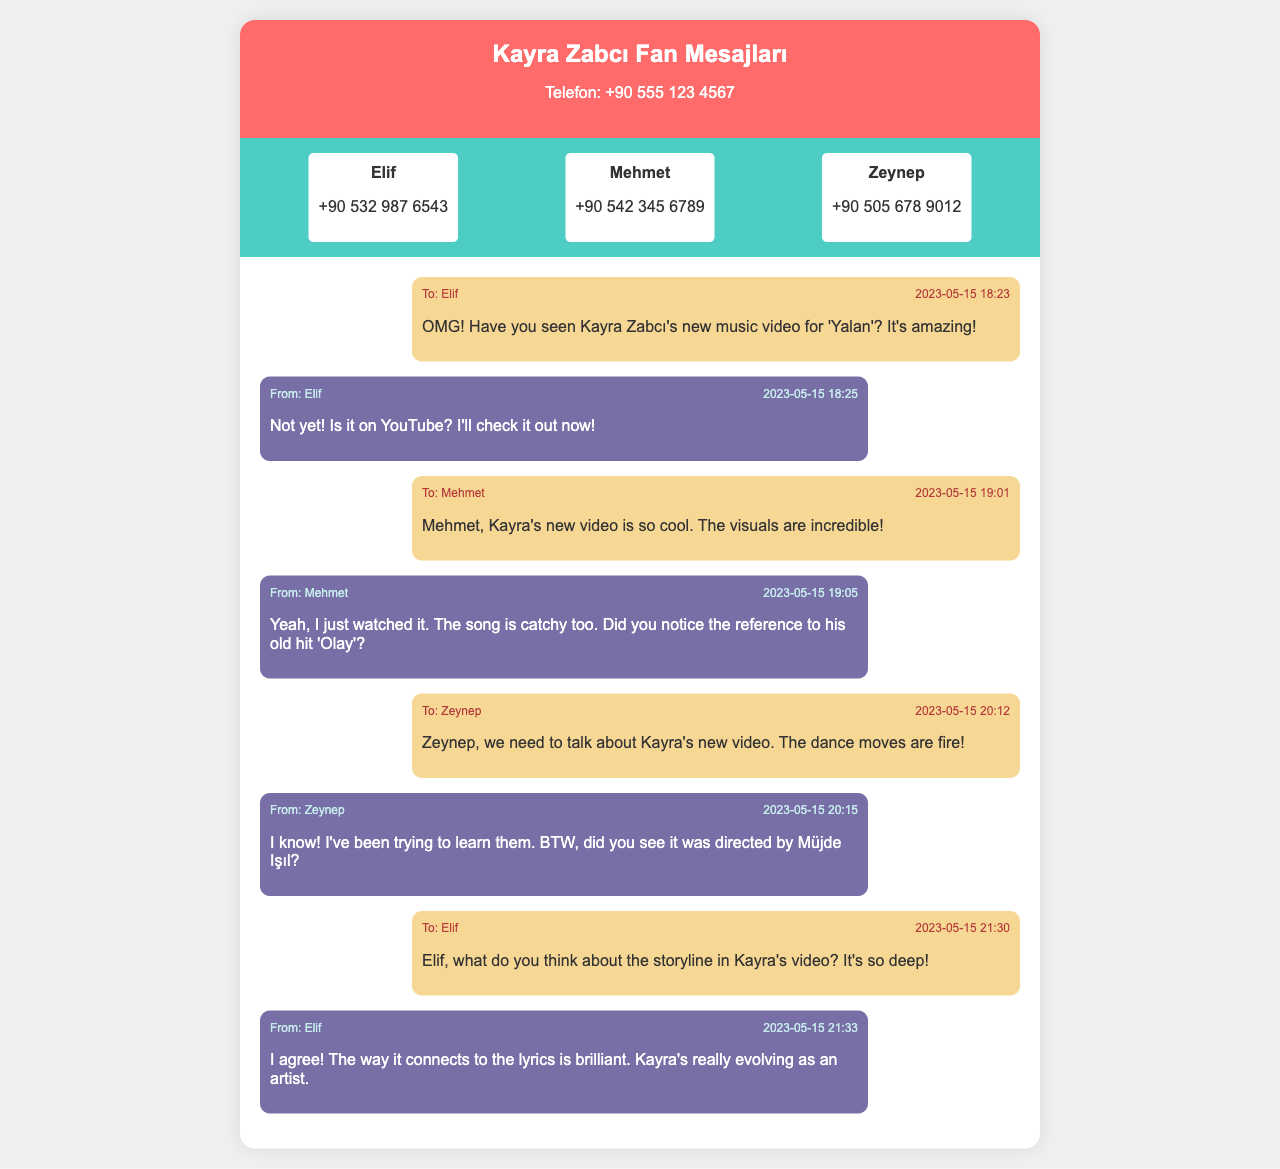What is the title of Kayra Zabcı's new music video? The title of the new music video mentioned in the conversation is 'Yalan'.
Answer: 'Yalan' Who directed Kayra Zabcı's new music video? The message from Zeynep mentions that the video was directed by Müjde Işıl.
Answer: Müjde Işıl What is Elif's phone number? Elif's contact information shows her phone number as +90 532 987 6543.
Answer: +90 532 987 6543 At what time did the message about the storyline arrive? The message asking about the storyline in Kayra's video was sent at 21:30.
Answer: 21:30 What refers to Kayra's old hit in the conversation? Mehmet points out the reference to Kayra's old hit 'Olay' in his message.
Answer: 'Olay' Who said "Kayra's really evolving as an artist"? Elif stated that Kayra is evolving as an artist in her response.
Answer: Elif How many friends did the user text about the music video? The user exchanged messages with three friends: Elif, Mehmet, and Zeynep.
Answer: Three What is a recurring theme discussed in the messages? The friends discuss the visuals, dance moves, and storyline of Kayra's music video.
Answer: Visuals, dance moves, storyline At what time was the first message sent? The first message mentioning the music video was sent at 18:23.
Answer: 18:23 